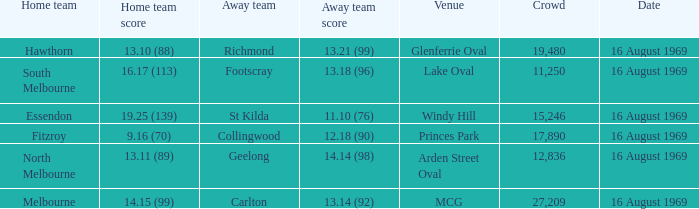Who was home at Princes Park? 9.16 (70). 